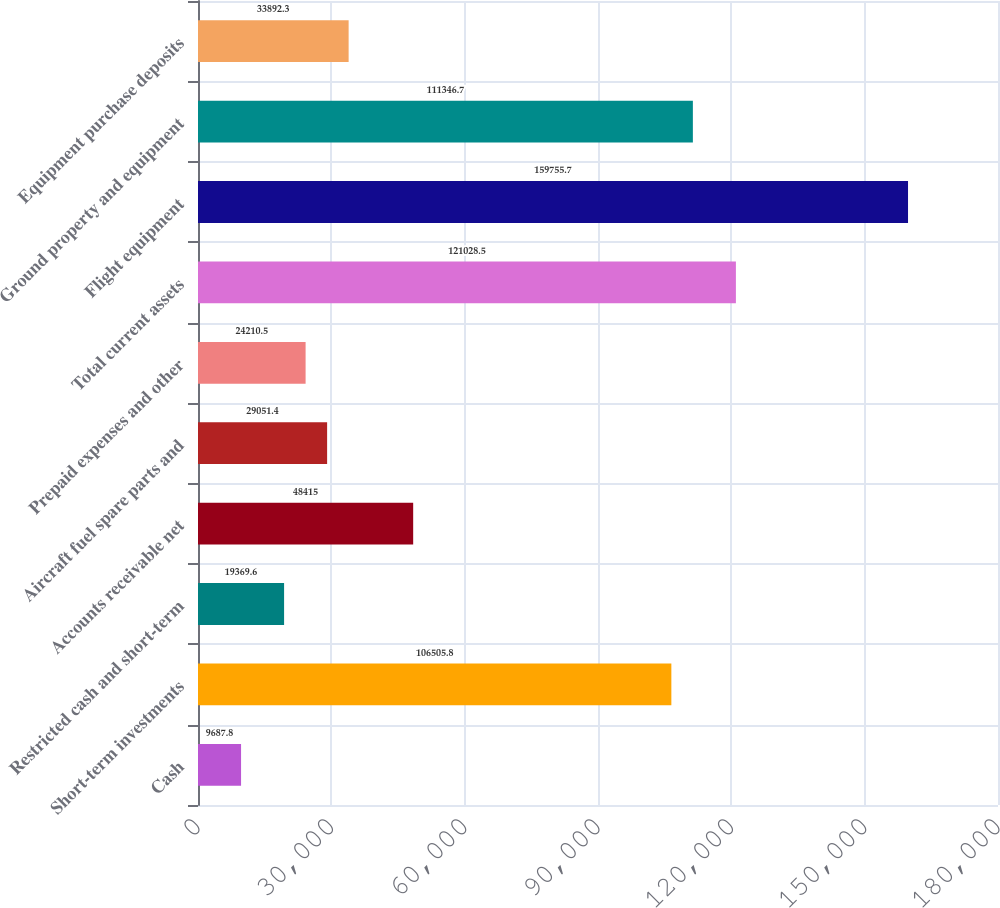Convert chart to OTSL. <chart><loc_0><loc_0><loc_500><loc_500><bar_chart><fcel>Cash<fcel>Short-term investments<fcel>Restricted cash and short-term<fcel>Accounts receivable net<fcel>Aircraft fuel spare parts and<fcel>Prepaid expenses and other<fcel>Total current assets<fcel>Flight equipment<fcel>Ground property and equipment<fcel>Equipment purchase deposits<nl><fcel>9687.8<fcel>106506<fcel>19369.6<fcel>48415<fcel>29051.4<fcel>24210.5<fcel>121028<fcel>159756<fcel>111347<fcel>33892.3<nl></chart> 